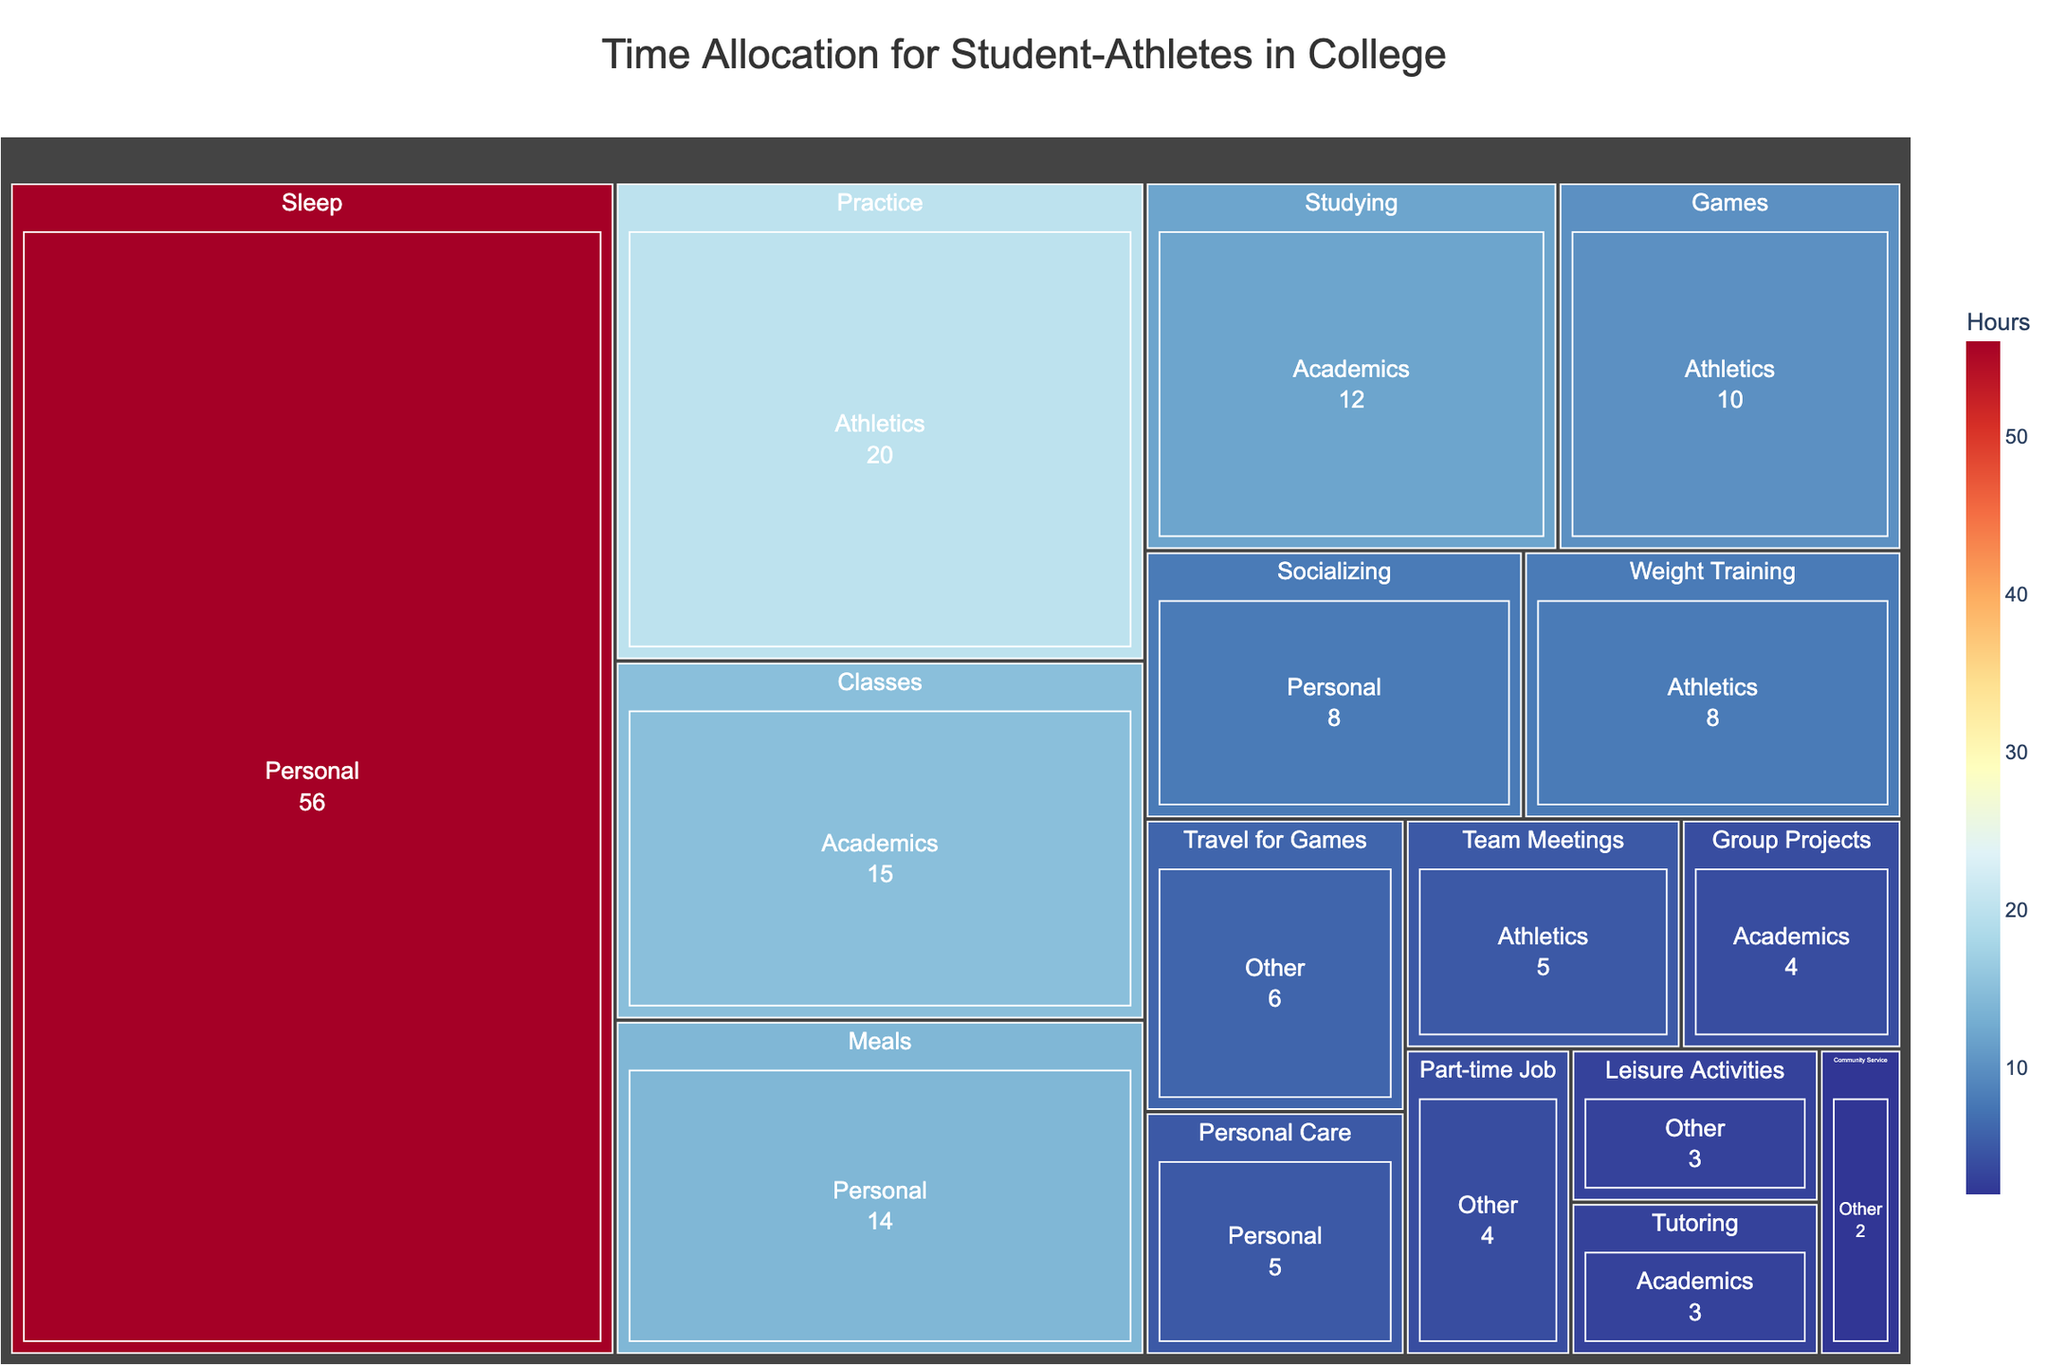what is the title of the treemap? The title of the treemap is displayed prominently at the top center of the figure. It reads "Time Allocation for Student-Athletes in College."
Answer: Time Allocation for Student-Athletes in College Which activity under the 'Personal' category takes the most time? To find the activity under the 'Personal' category that takes the most time, we look for the largest segment or the highest value under 'Personal'. The largest segment and value is 'Sleep' which takes 56 hours.
Answer: Sleep How many hours are spent on 'Athletics' activities in total? To find the total hours spent on 'Athletics', sum the hours of all activities under this category: Practice (20), Games (10), Team Meetings (5), and Weight Training (8). The sum is 20 + 10 + 5 + 8 = 43 hours.
Answer: 43 Which category has the smallest total time allocation? To find the category with the smallest total time allocation, sum the hours of activities in each category and compare. 'Other' category has: Travel for Games (6), Community Service (2), Part-time Job (4), and Leisure Activities (3) for a total of 6 + 2 + 4 + 3 = 15 hours, which is the smallest total.
Answer: Other Are there more hours spent on 'Studying' or 'Weight Training'? To compare hours spent on 'Studying' and 'Weight Training', look at their values. 'Studying' has 12 hours, while 'Weight Training' has 8 hours.
Answer: Studying What is the sum of hours spent on 'Academics'? To calculate the total hours spent on 'Academics', sum the hours for Classes (15), Studying (12), Tutoring (3), and Group Projects (4). The sum is 15 + 12 + 3 + 4 = 34 hours.
Answer: 34 What proportion of the total time is spent on 'Community Service'? First, calculate the total hours for all activities: Athletics (43 hours) + Academics (34 hours) + Personal (83 hours) + Other (15 hours) = 175 hours. Then, find the proportion for 'Community Service': 2 hours / 175 total hours = approximately 0.0114 or 1.14%.
Answer: 1.14% What is the largest single activity in terms of time allocation? To find the largest single activity, compare the values of all activities. 'Sleep' under 'Personal' category has the highest allocation of 56 hours.
Answer: Sleep How much time is allocated to 'Personal' activities? Add up the hours spent on all 'Personal' activities: Sleep (56), Meals (14), Socializing (8), Personal Care (5). The total is 56 + 14 + 8 + 5 = 83 hours.
Answer: 83 Compared to 'Practice', how much less time is spent on 'Classes'? To find out how much less time is spent on 'Classes' (15 hours) compared to 'Practice' (20 hours), subtract the hours of 'Classes' from 'Practice': 20 - 15 = 5 hours.
Answer: 5 